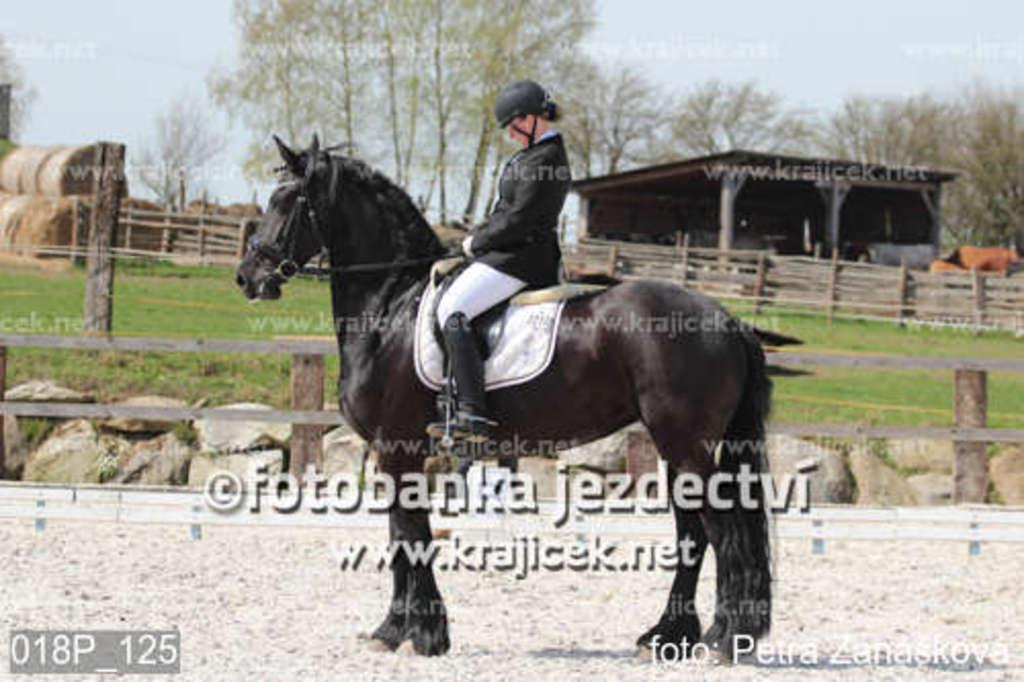What is the man doing in the image? The man is sitting on a horse. What is the man wearing on his head? The man is wearing a helmet. What is the position of the horse in the image? The horse is on the ground. What can be seen in the background of the image? There is a railing, a shed, grass, trees, and the sky visible in the background. How many jellyfish are swimming in the background of the image? There are no jellyfish present in the image; it features a man sitting on a horse with various background elements. 